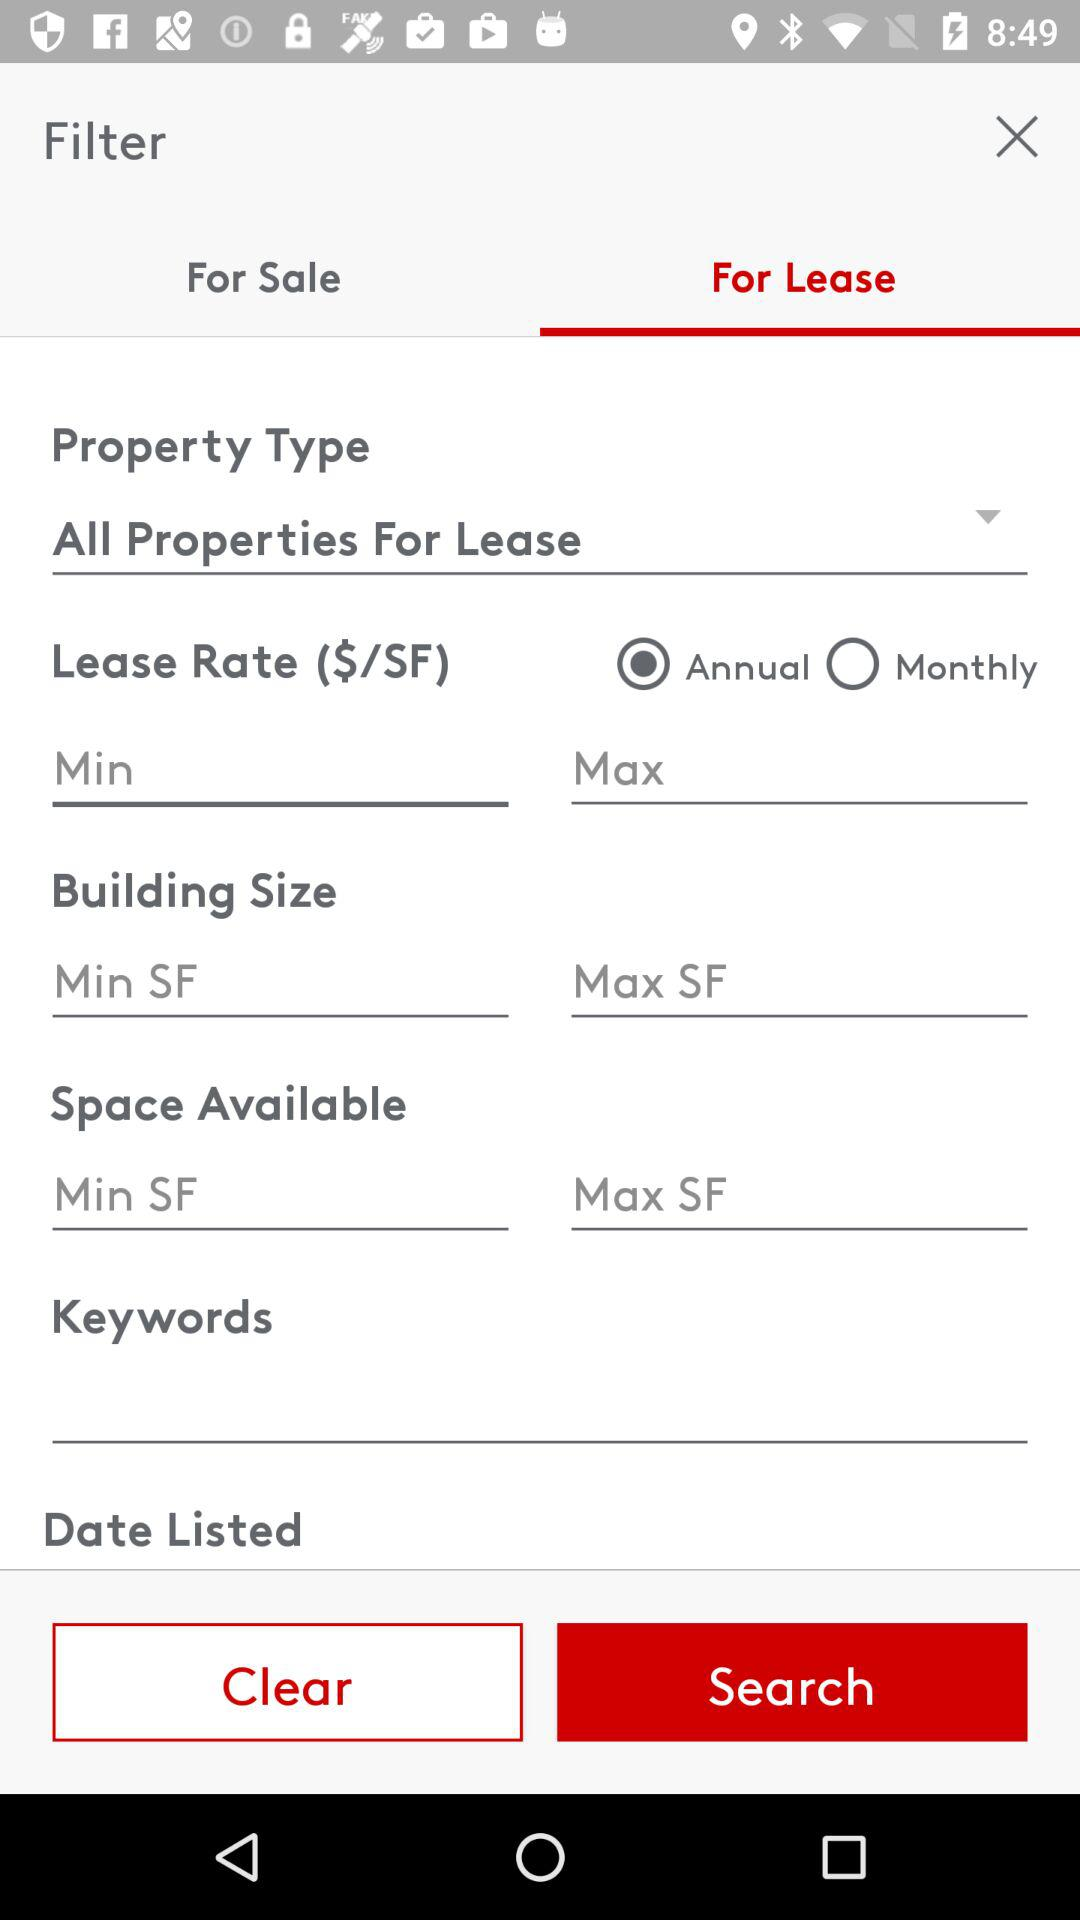What option is selected for "Lease Rate ($/SF)"? The selected option is "Annual". 